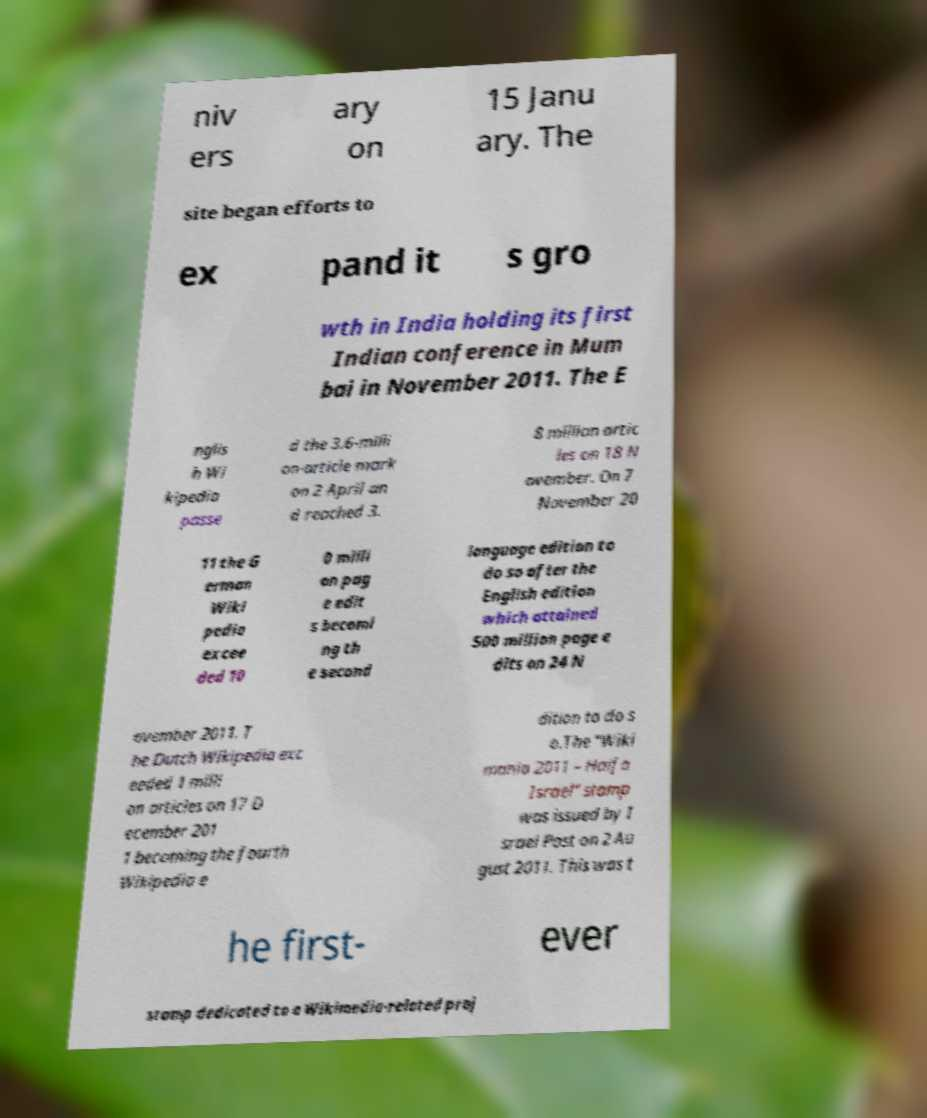Can you accurately transcribe the text from the provided image for me? niv ers ary on 15 Janu ary. The site began efforts to ex pand it s gro wth in India holding its first Indian conference in Mum bai in November 2011. The E nglis h Wi kipedia passe d the 3.6-milli on-article mark on 2 April an d reached 3. 8 million artic les on 18 N ovember. On 7 November 20 11 the G erman Wiki pedia excee ded 10 0 milli on pag e edit s becomi ng th e second language edition to do so after the English edition which attained 500 million page e dits on 24 N ovember 2011. T he Dutch Wikipedia exc eeded 1 milli on articles on 17 D ecember 201 1 becoming the fourth Wikipedia e dition to do s o.The "Wiki mania 2011 – Haifa Israel" stamp was issued by I srael Post on 2 Au gust 2011. This was t he first- ever stamp dedicated to a Wikimedia-related proj 